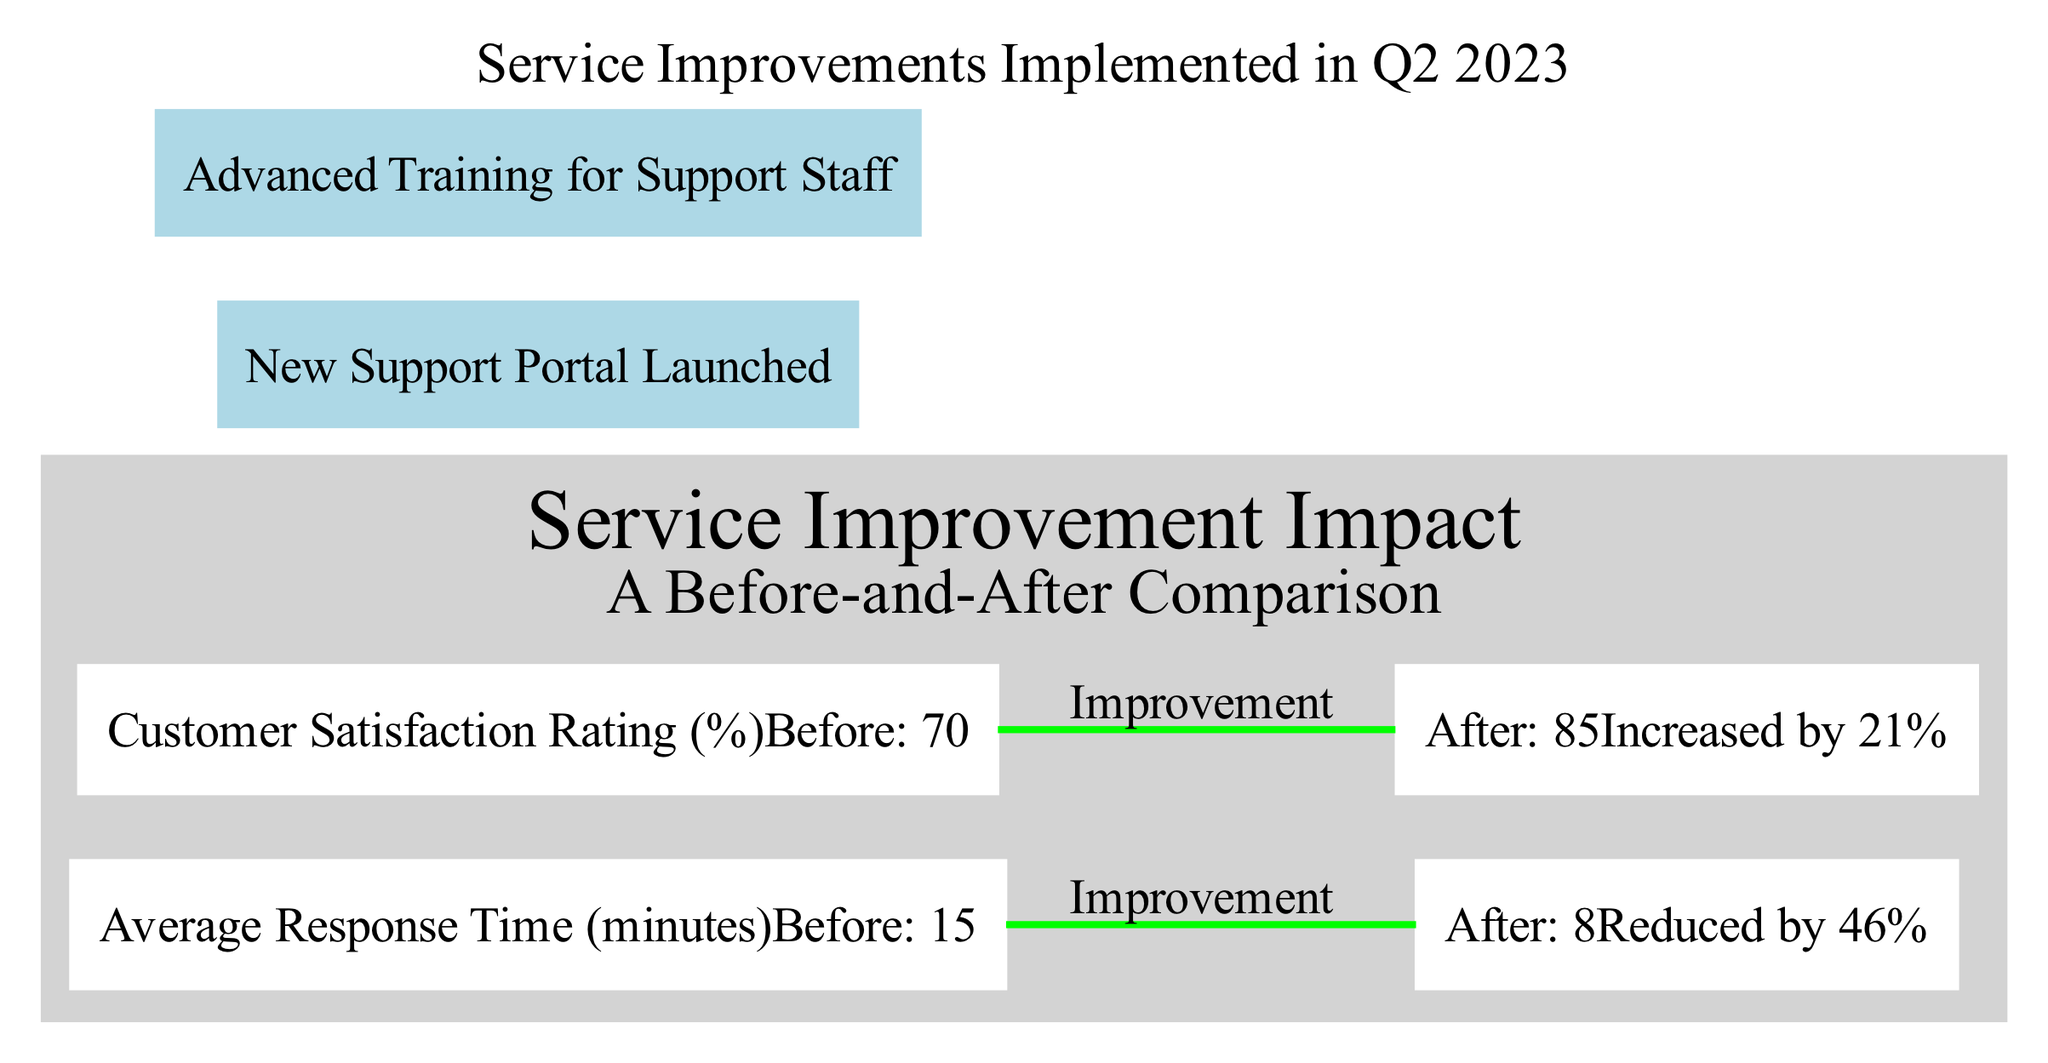What is the average response time before the service improvements? The diagram shows a bar for "Average Response Time (minutes)", which indicates that the value before the service improvements was 15 minutes.
Answer: 15 minutes What is the customer satisfaction rating after the service improvements? We look at the bar for "Customer Satisfaction Rating (%)", which displays the value after the service improvements, which is 85%.
Answer: 85% By how much was the average response time reduced? The diagram provides the percentage change in average response time as noted in the legend, which indicates a reduction of 46%.
Answer: 46% What was the customer satisfaction rating before the service improvements? The diagram indicates the previous customer satisfaction rating before the improvements on the bar, which was 70%.
Answer: 70% Which quarter were the service improvements implemented? The annotation at the top-center of the diagram states that service improvements were implemented in Q2 2023.
Answer: Q2 2023 What is the percentage increase in customer satisfaction rating? We can determine the change using the values before and after the service improvements, which shows an increase of 21% as highlighted in the diagram.
Answer: 21% How many bars are present in the diagram? The diagram includes two bars: one for Average Response Time and one for Customer Satisfaction Rating, totaling two bars.
Answer: 2 What specific service enhancement was launched in the bottom-left annotation? The bottom-left annotation mentions that a "New Support Portal" was launched as a part of the service enhancements.
Answer: New Support Portal What specific training was provided for support staff as per the diagram? The bottom-right annotation discusses "Advanced Training for Support Staff" which was implemented as part of the service improvements.
Answer: Advanced Training for Support Staff 